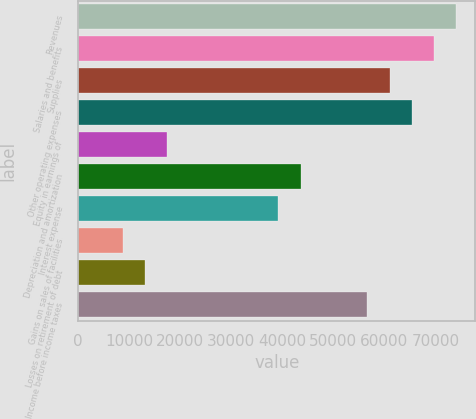<chart> <loc_0><loc_0><loc_500><loc_500><bar_chart><fcel>Revenues<fcel>Salaries and benefits<fcel>Supplies<fcel>Other operating expenses<fcel>Equity in earnings of<fcel>Depreciation and amortization<fcel>Interest expense<fcel>Gains on sales of facilities<fcel>Losses on retirement of debt<fcel>Income before income taxes<nl><fcel>74139.6<fcel>69778.9<fcel>61057.2<fcel>65418<fcel>17449.2<fcel>43614<fcel>39253.2<fcel>8727.57<fcel>13088.4<fcel>56696.4<nl></chart> 